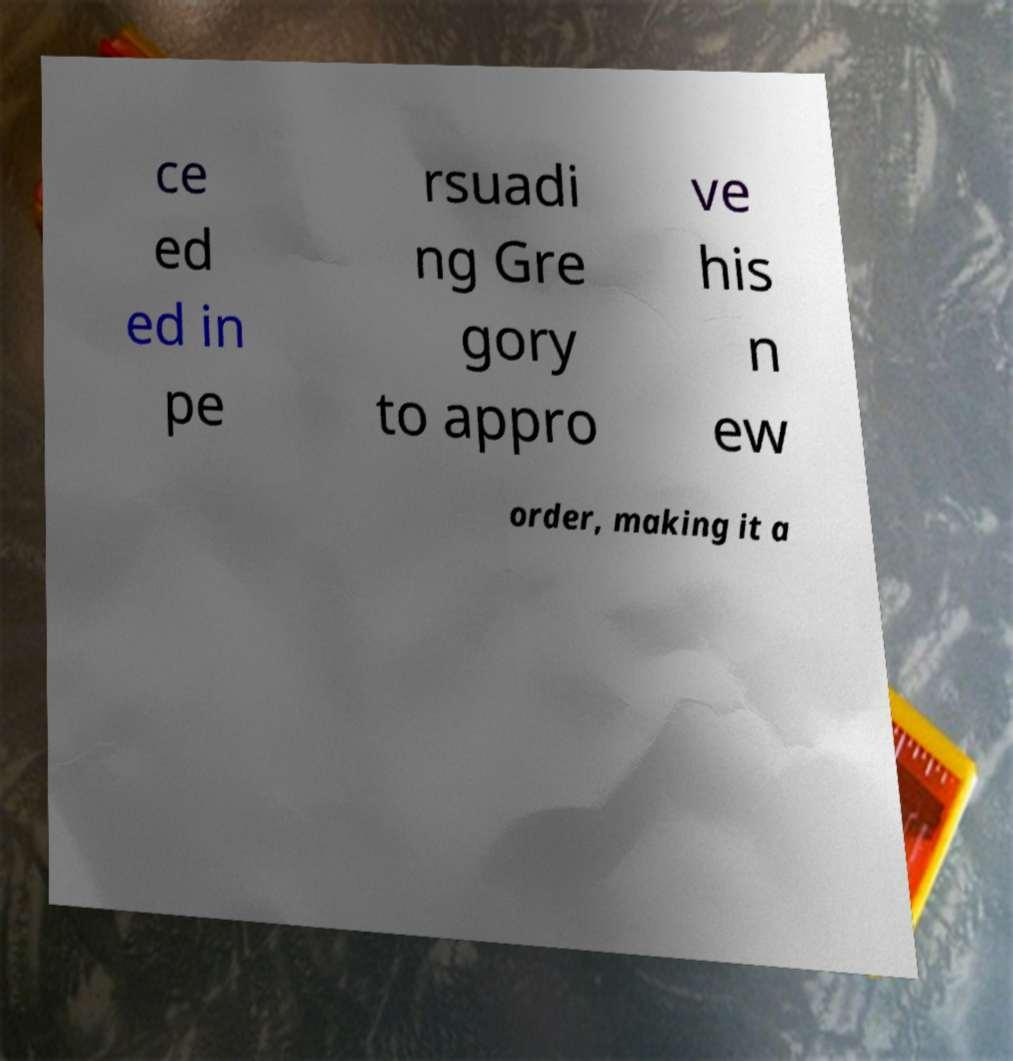There's text embedded in this image that I need extracted. Can you transcribe it verbatim? ce ed ed in pe rsuadi ng Gre gory to appro ve his n ew order, making it a 